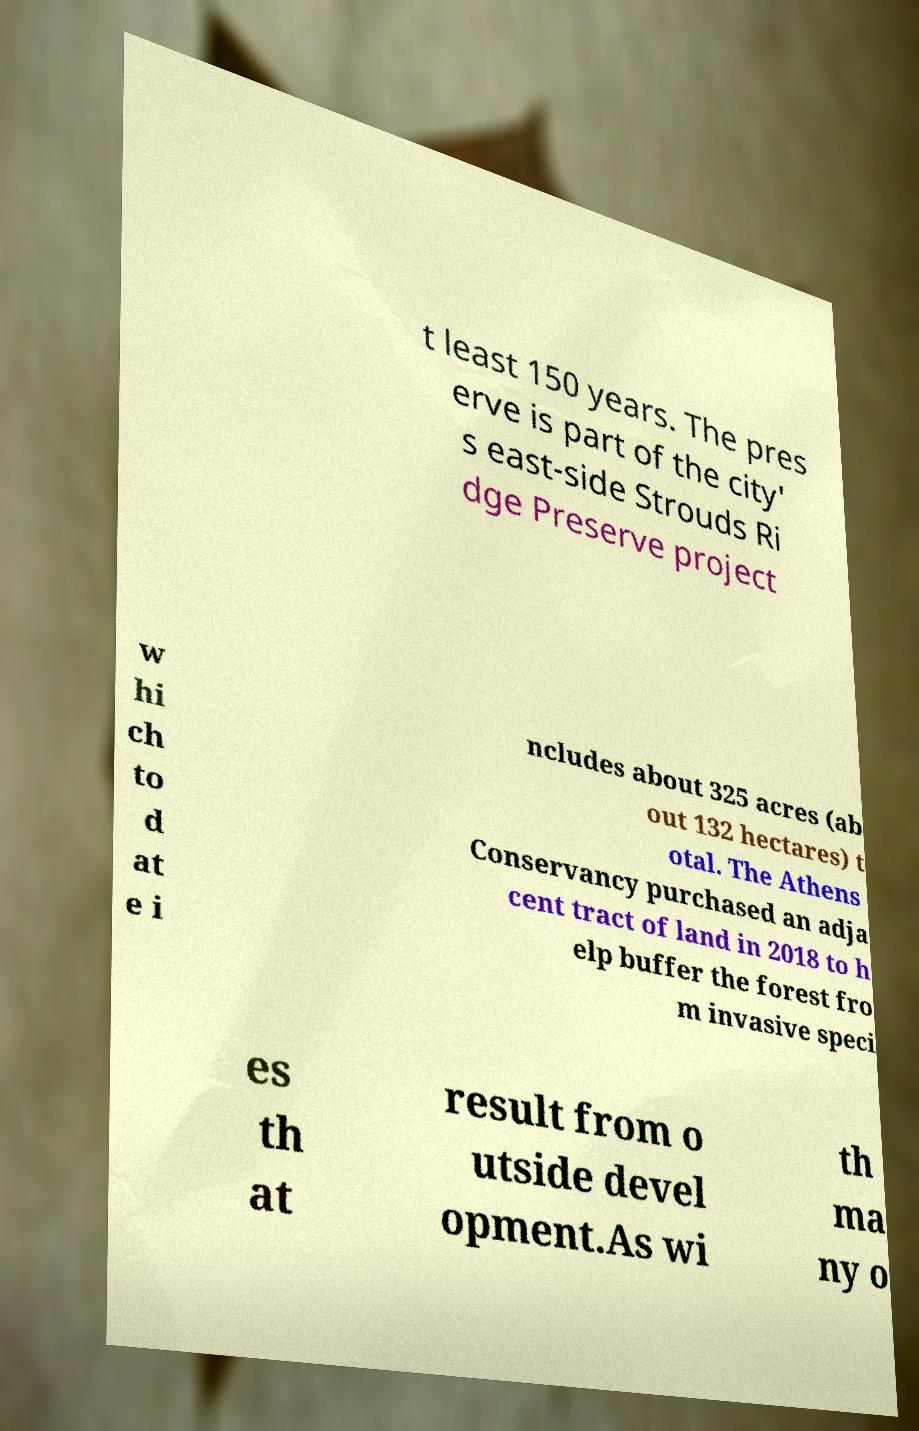Could you assist in decoding the text presented in this image and type it out clearly? t least 150 years. The pres erve is part of the city' s east-side Strouds Ri dge Preserve project w hi ch to d at e i ncludes about 325 acres (ab out 132 hectares) t otal. The Athens Conservancy purchased an adja cent tract of land in 2018 to h elp buffer the forest fro m invasive speci es th at result from o utside devel opment.As wi th ma ny o 